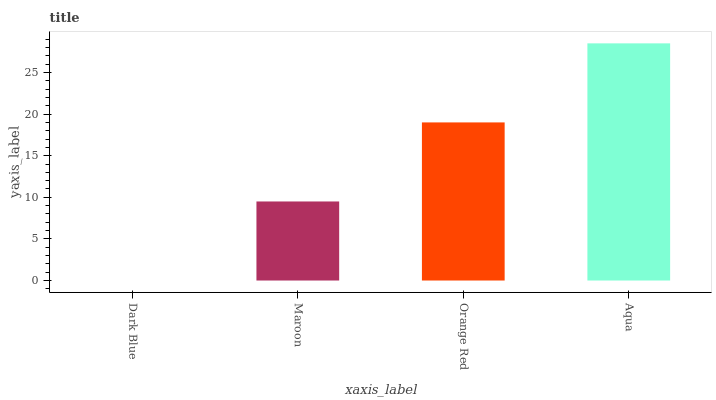Is Dark Blue the minimum?
Answer yes or no. Yes. Is Aqua the maximum?
Answer yes or no. Yes. Is Maroon the minimum?
Answer yes or no. No. Is Maroon the maximum?
Answer yes or no. No. Is Maroon greater than Dark Blue?
Answer yes or no. Yes. Is Dark Blue less than Maroon?
Answer yes or no. Yes. Is Dark Blue greater than Maroon?
Answer yes or no. No. Is Maroon less than Dark Blue?
Answer yes or no. No. Is Orange Red the high median?
Answer yes or no. Yes. Is Maroon the low median?
Answer yes or no. Yes. Is Dark Blue the high median?
Answer yes or no. No. Is Orange Red the low median?
Answer yes or no. No. 